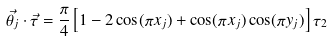<formula> <loc_0><loc_0><loc_500><loc_500>\vec { \theta _ { j } } \cdot \vec { \tau } = \frac { \pi } { 4 } \left [ 1 - 2 \cos ( \pi x _ { j } ) + \cos ( \pi x _ { j } ) \cos ( \pi y _ { j } ) \right ] \tau _ { 2 }</formula> 